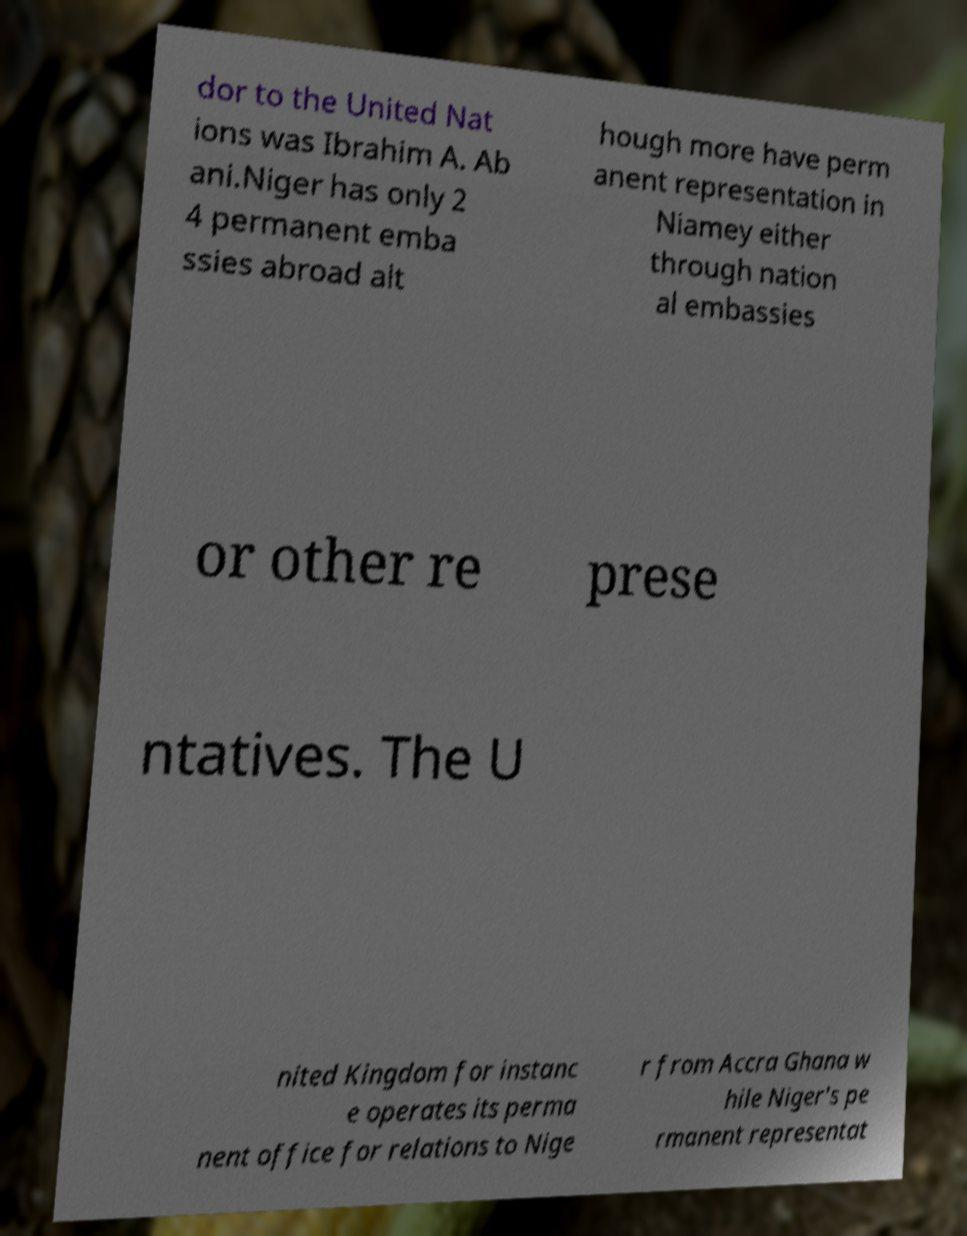What messages or text are displayed in this image? I need them in a readable, typed format. dor to the United Nat ions was Ibrahim A. Ab ani.Niger has only 2 4 permanent emba ssies abroad alt hough more have perm anent representation in Niamey either through nation al embassies or other re prese ntatives. The U nited Kingdom for instanc e operates its perma nent office for relations to Nige r from Accra Ghana w hile Niger's pe rmanent representat 